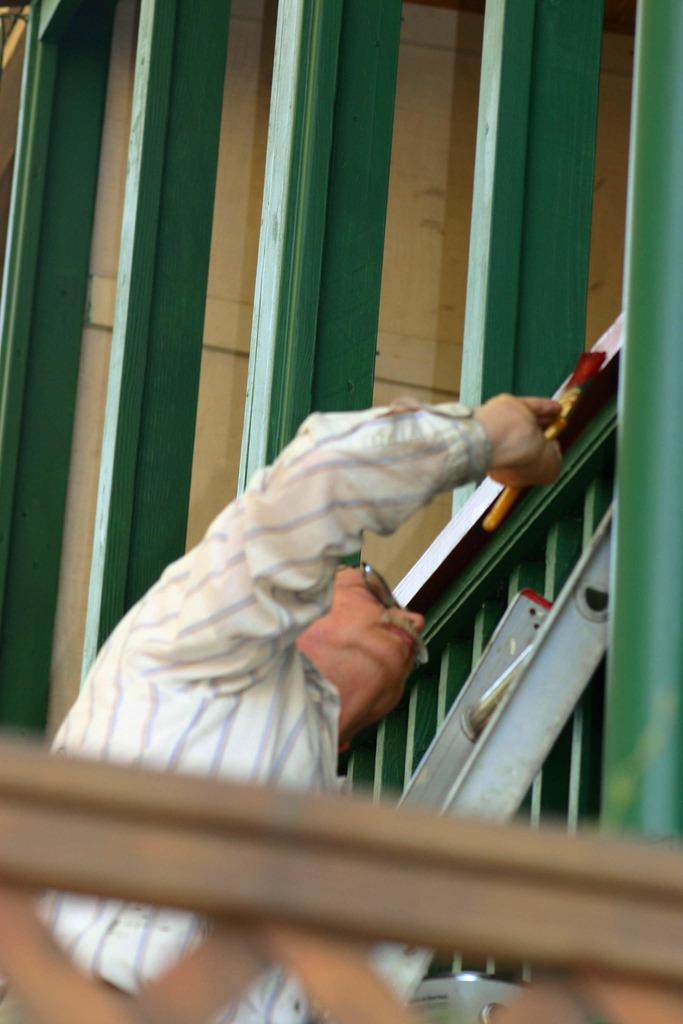Who is present in the image? There is a man in the image. What can be seen in the image besides the man? There are wooden grills in the image. What type of thunder can be heard in the image? There is no thunder present in the image, as it is a visual medium and does not contain sound. 